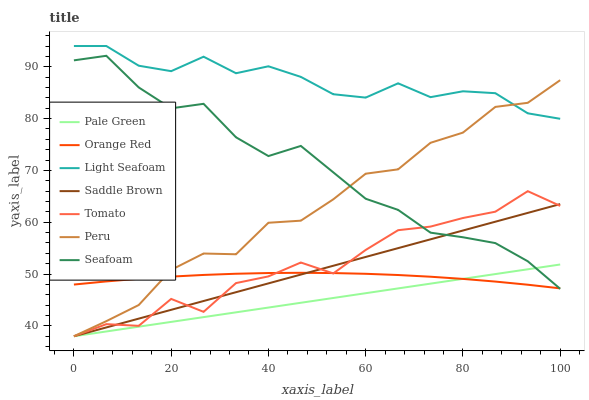Does Pale Green have the minimum area under the curve?
Answer yes or no. Yes. Does Light Seafoam have the maximum area under the curve?
Answer yes or no. Yes. Does Seafoam have the minimum area under the curve?
Answer yes or no. No. Does Seafoam have the maximum area under the curve?
Answer yes or no. No. Is Pale Green the smoothest?
Answer yes or no. Yes. Is Tomato the roughest?
Answer yes or no. Yes. Is Seafoam the smoothest?
Answer yes or no. No. Is Seafoam the roughest?
Answer yes or no. No. Does Tomato have the lowest value?
Answer yes or no. Yes. Does Seafoam have the lowest value?
Answer yes or no. No. Does Light Seafoam have the highest value?
Answer yes or no. Yes. Does Seafoam have the highest value?
Answer yes or no. No. Is Pale Green less than Light Seafoam?
Answer yes or no. Yes. Is Light Seafoam greater than Orange Red?
Answer yes or no. Yes. Does Tomato intersect Seafoam?
Answer yes or no. Yes. Is Tomato less than Seafoam?
Answer yes or no. No. Is Tomato greater than Seafoam?
Answer yes or no. No. Does Pale Green intersect Light Seafoam?
Answer yes or no. No. 